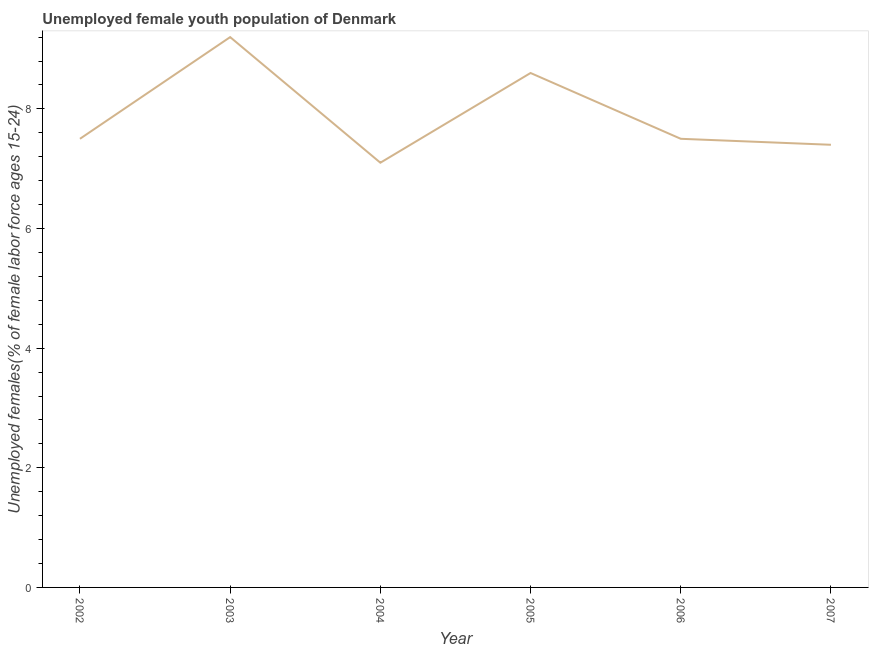What is the unemployed female youth in 2002?
Ensure brevity in your answer.  7.5. Across all years, what is the maximum unemployed female youth?
Offer a very short reply. 9.2. Across all years, what is the minimum unemployed female youth?
Make the answer very short. 7.1. What is the sum of the unemployed female youth?
Your answer should be very brief. 47.3. What is the difference between the unemployed female youth in 2004 and 2007?
Provide a short and direct response. -0.3. What is the average unemployed female youth per year?
Ensure brevity in your answer.  7.88. What is the median unemployed female youth?
Your answer should be very brief. 7.5. What is the ratio of the unemployed female youth in 2003 to that in 2007?
Offer a very short reply. 1.24. Is the unemployed female youth in 2004 less than that in 2006?
Your response must be concise. Yes. Is the difference between the unemployed female youth in 2003 and 2004 greater than the difference between any two years?
Give a very brief answer. Yes. What is the difference between the highest and the second highest unemployed female youth?
Keep it short and to the point. 0.6. What is the difference between the highest and the lowest unemployed female youth?
Offer a very short reply. 2.1. How many lines are there?
Make the answer very short. 1. Does the graph contain grids?
Ensure brevity in your answer.  No. What is the title of the graph?
Provide a succinct answer. Unemployed female youth population of Denmark. What is the label or title of the Y-axis?
Your answer should be very brief. Unemployed females(% of female labor force ages 15-24). What is the Unemployed females(% of female labor force ages 15-24) in 2003?
Give a very brief answer. 9.2. What is the Unemployed females(% of female labor force ages 15-24) in 2004?
Keep it short and to the point. 7.1. What is the Unemployed females(% of female labor force ages 15-24) of 2005?
Give a very brief answer. 8.6. What is the Unemployed females(% of female labor force ages 15-24) of 2007?
Provide a succinct answer. 7.4. What is the difference between the Unemployed females(% of female labor force ages 15-24) in 2002 and 2004?
Provide a short and direct response. 0.4. What is the difference between the Unemployed females(% of female labor force ages 15-24) in 2003 and 2004?
Give a very brief answer. 2.1. What is the difference between the Unemployed females(% of female labor force ages 15-24) in 2003 and 2007?
Ensure brevity in your answer.  1.8. What is the difference between the Unemployed females(% of female labor force ages 15-24) in 2004 and 2006?
Ensure brevity in your answer.  -0.4. What is the difference between the Unemployed females(% of female labor force ages 15-24) in 2004 and 2007?
Your answer should be very brief. -0.3. What is the difference between the Unemployed females(% of female labor force ages 15-24) in 2005 and 2007?
Provide a succinct answer. 1.2. What is the ratio of the Unemployed females(% of female labor force ages 15-24) in 2002 to that in 2003?
Your answer should be compact. 0.81. What is the ratio of the Unemployed females(% of female labor force ages 15-24) in 2002 to that in 2004?
Provide a short and direct response. 1.06. What is the ratio of the Unemployed females(% of female labor force ages 15-24) in 2002 to that in 2005?
Give a very brief answer. 0.87. What is the ratio of the Unemployed females(% of female labor force ages 15-24) in 2003 to that in 2004?
Your answer should be compact. 1.3. What is the ratio of the Unemployed females(% of female labor force ages 15-24) in 2003 to that in 2005?
Your response must be concise. 1.07. What is the ratio of the Unemployed females(% of female labor force ages 15-24) in 2003 to that in 2006?
Make the answer very short. 1.23. What is the ratio of the Unemployed females(% of female labor force ages 15-24) in 2003 to that in 2007?
Provide a succinct answer. 1.24. What is the ratio of the Unemployed females(% of female labor force ages 15-24) in 2004 to that in 2005?
Offer a very short reply. 0.83. What is the ratio of the Unemployed females(% of female labor force ages 15-24) in 2004 to that in 2006?
Offer a very short reply. 0.95. What is the ratio of the Unemployed females(% of female labor force ages 15-24) in 2005 to that in 2006?
Your response must be concise. 1.15. What is the ratio of the Unemployed females(% of female labor force ages 15-24) in 2005 to that in 2007?
Your answer should be very brief. 1.16. What is the ratio of the Unemployed females(% of female labor force ages 15-24) in 2006 to that in 2007?
Provide a short and direct response. 1.01. 